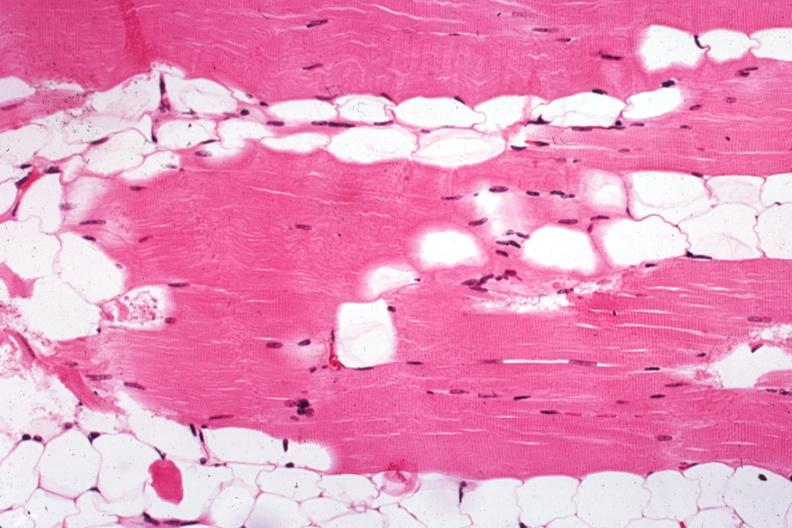does this image show excellent example case of myasthenia gravis treated?
Answer the question using a single word or phrase. Yes 